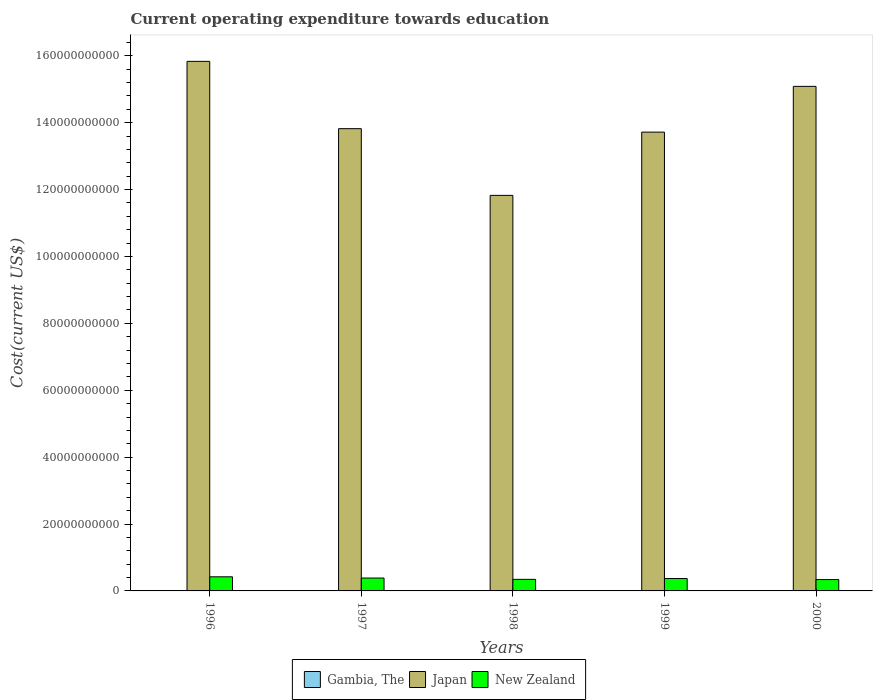How many different coloured bars are there?
Your answer should be very brief. 3. How many groups of bars are there?
Give a very brief answer. 5. How many bars are there on the 5th tick from the left?
Offer a terse response. 3. How many bars are there on the 5th tick from the right?
Give a very brief answer. 3. What is the label of the 5th group of bars from the left?
Your answer should be compact. 2000. In how many cases, is the number of bars for a given year not equal to the number of legend labels?
Ensure brevity in your answer.  0. What is the expenditure towards education in Japan in 2000?
Your answer should be very brief. 1.51e+11. Across all years, what is the maximum expenditure towards education in Japan?
Make the answer very short. 1.58e+11. Across all years, what is the minimum expenditure towards education in New Zealand?
Your response must be concise. 3.40e+09. What is the total expenditure towards education in Japan in the graph?
Keep it short and to the point. 7.03e+11. What is the difference between the expenditure towards education in Japan in 1997 and that in 2000?
Your answer should be compact. -1.26e+1. What is the difference between the expenditure towards education in Japan in 1998 and the expenditure towards education in New Zealand in 1996?
Provide a short and direct response. 1.14e+11. What is the average expenditure towards education in Japan per year?
Provide a short and direct response. 1.41e+11. In the year 2000, what is the difference between the expenditure towards education in Gambia, The and expenditure towards education in Japan?
Ensure brevity in your answer.  -1.51e+11. What is the ratio of the expenditure towards education in Gambia, The in 1996 to that in 1997?
Give a very brief answer. 1.07. Is the expenditure towards education in Gambia, The in 1997 less than that in 1998?
Provide a short and direct response. No. Is the difference between the expenditure towards education in Gambia, The in 1996 and 1997 greater than the difference between the expenditure towards education in Japan in 1996 and 1997?
Make the answer very short. No. What is the difference between the highest and the second highest expenditure towards education in New Zealand?
Make the answer very short. 3.69e+08. What is the difference between the highest and the lowest expenditure towards education in Gambia, The?
Keep it short and to the point. 3.53e+06. Is the sum of the expenditure towards education in New Zealand in 1997 and 1999 greater than the maximum expenditure towards education in Gambia, The across all years?
Give a very brief answer. Yes. What does the 3rd bar from the left in 2000 represents?
Your answer should be very brief. New Zealand. What does the 3rd bar from the right in 1996 represents?
Offer a terse response. Gambia, The. Is it the case that in every year, the sum of the expenditure towards education in Gambia, The and expenditure towards education in Japan is greater than the expenditure towards education in New Zealand?
Provide a short and direct response. Yes. How many bars are there?
Offer a very short reply. 15. How many years are there in the graph?
Ensure brevity in your answer.  5. How are the legend labels stacked?
Offer a terse response. Horizontal. What is the title of the graph?
Offer a terse response. Current operating expenditure towards education. Does "Seychelles" appear as one of the legend labels in the graph?
Your answer should be compact. No. What is the label or title of the X-axis?
Ensure brevity in your answer.  Years. What is the label or title of the Y-axis?
Provide a succinct answer. Cost(current US$). What is the Cost(current US$) of Gambia, The in 1996?
Make the answer very short. 1.33e+07. What is the Cost(current US$) in Japan in 1996?
Your response must be concise. 1.58e+11. What is the Cost(current US$) in New Zealand in 1996?
Offer a terse response. 4.22e+09. What is the Cost(current US$) of Gambia, The in 1997?
Your answer should be very brief. 1.25e+07. What is the Cost(current US$) in Japan in 1997?
Your answer should be very brief. 1.38e+11. What is the Cost(current US$) in New Zealand in 1997?
Give a very brief answer. 3.85e+09. What is the Cost(current US$) in Gambia, The in 1998?
Make the answer very short. 1.22e+07. What is the Cost(current US$) of Japan in 1998?
Provide a succinct answer. 1.18e+11. What is the Cost(current US$) of New Zealand in 1998?
Your response must be concise. 3.46e+09. What is the Cost(current US$) of Gambia, The in 1999?
Provide a succinct answer. 1.10e+07. What is the Cost(current US$) of Japan in 1999?
Your response must be concise. 1.37e+11. What is the Cost(current US$) of New Zealand in 1999?
Offer a very short reply. 3.70e+09. What is the Cost(current US$) of Gambia, The in 2000?
Offer a terse response. 9.78e+06. What is the Cost(current US$) in Japan in 2000?
Keep it short and to the point. 1.51e+11. What is the Cost(current US$) in New Zealand in 2000?
Make the answer very short. 3.40e+09. Across all years, what is the maximum Cost(current US$) of Gambia, The?
Ensure brevity in your answer.  1.33e+07. Across all years, what is the maximum Cost(current US$) of Japan?
Keep it short and to the point. 1.58e+11. Across all years, what is the maximum Cost(current US$) of New Zealand?
Your answer should be very brief. 4.22e+09. Across all years, what is the minimum Cost(current US$) in Gambia, The?
Provide a succinct answer. 9.78e+06. Across all years, what is the minimum Cost(current US$) in Japan?
Give a very brief answer. 1.18e+11. Across all years, what is the minimum Cost(current US$) in New Zealand?
Provide a short and direct response. 3.40e+09. What is the total Cost(current US$) in Gambia, The in the graph?
Keep it short and to the point. 5.88e+07. What is the total Cost(current US$) of Japan in the graph?
Your response must be concise. 7.03e+11. What is the total Cost(current US$) in New Zealand in the graph?
Provide a short and direct response. 1.86e+1. What is the difference between the Cost(current US$) of Gambia, The in 1996 and that in 1997?
Provide a succinct answer. 8.36e+05. What is the difference between the Cost(current US$) in Japan in 1996 and that in 1997?
Provide a short and direct response. 2.01e+1. What is the difference between the Cost(current US$) in New Zealand in 1996 and that in 1997?
Your response must be concise. 3.69e+08. What is the difference between the Cost(current US$) in Gambia, The in 1996 and that in 1998?
Offer a very short reply. 1.09e+06. What is the difference between the Cost(current US$) of Japan in 1996 and that in 1998?
Your answer should be very brief. 4.01e+1. What is the difference between the Cost(current US$) of New Zealand in 1996 and that in 1998?
Your response must be concise. 7.59e+08. What is the difference between the Cost(current US$) in Gambia, The in 1996 and that in 1999?
Your answer should be compact. 2.31e+06. What is the difference between the Cost(current US$) in Japan in 1996 and that in 1999?
Give a very brief answer. 2.12e+1. What is the difference between the Cost(current US$) of New Zealand in 1996 and that in 1999?
Make the answer very short. 5.18e+08. What is the difference between the Cost(current US$) of Gambia, The in 1996 and that in 2000?
Offer a terse response. 3.53e+06. What is the difference between the Cost(current US$) in Japan in 1996 and that in 2000?
Your response must be concise. 7.48e+09. What is the difference between the Cost(current US$) of New Zealand in 1996 and that in 2000?
Your response must be concise. 8.20e+08. What is the difference between the Cost(current US$) of Gambia, The in 1997 and that in 1998?
Your response must be concise. 2.53e+05. What is the difference between the Cost(current US$) in Japan in 1997 and that in 1998?
Give a very brief answer. 1.99e+1. What is the difference between the Cost(current US$) of New Zealand in 1997 and that in 1998?
Make the answer very short. 3.91e+08. What is the difference between the Cost(current US$) in Gambia, The in 1997 and that in 1999?
Give a very brief answer. 1.48e+06. What is the difference between the Cost(current US$) in Japan in 1997 and that in 1999?
Your answer should be very brief. 1.03e+09. What is the difference between the Cost(current US$) of New Zealand in 1997 and that in 1999?
Offer a very short reply. 1.50e+08. What is the difference between the Cost(current US$) in Gambia, The in 1997 and that in 2000?
Give a very brief answer. 2.69e+06. What is the difference between the Cost(current US$) of Japan in 1997 and that in 2000?
Offer a very short reply. -1.26e+1. What is the difference between the Cost(current US$) of New Zealand in 1997 and that in 2000?
Ensure brevity in your answer.  4.51e+08. What is the difference between the Cost(current US$) in Gambia, The in 1998 and that in 1999?
Ensure brevity in your answer.  1.22e+06. What is the difference between the Cost(current US$) in Japan in 1998 and that in 1999?
Your answer should be very brief. -1.89e+1. What is the difference between the Cost(current US$) of New Zealand in 1998 and that in 1999?
Your answer should be compact. -2.41e+08. What is the difference between the Cost(current US$) in Gambia, The in 1998 and that in 2000?
Give a very brief answer. 2.44e+06. What is the difference between the Cost(current US$) of Japan in 1998 and that in 2000?
Offer a very short reply. -3.26e+1. What is the difference between the Cost(current US$) in New Zealand in 1998 and that in 2000?
Offer a very short reply. 6.07e+07. What is the difference between the Cost(current US$) of Gambia, The in 1999 and that in 2000?
Ensure brevity in your answer.  1.22e+06. What is the difference between the Cost(current US$) of Japan in 1999 and that in 2000?
Your answer should be very brief. -1.37e+1. What is the difference between the Cost(current US$) of New Zealand in 1999 and that in 2000?
Your response must be concise. 3.02e+08. What is the difference between the Cost(current US$) of Gambia, The in 1996 and the Cost(current US$) of Japan in 1997?
Offer a terse response. -1.38e+11. What is the difference between the Cost(current US$) in Gambia, The in 1996 and the Cost(current US$) in New Zealand in 1997?
Your answer should be very brief. -3.84e+09. What is the difference between the Cost(current US$) in Japan in 1996 and the Cost(current US$) in New Zealand in 1997?
Your response must be concise. 1.54e+11. What is the difference between the Cost(current US$) in Gambia, The in 1996 and the Cost(current US$) in Japan in 1998?
Ensure brevity in your answer.  -1.18e+11. What is the difference between the Cost(current US$) of Gambia, The in 1996 and the Cost(current US$) of New Zealand in 1998?
Make the answer very short. -3.45e+09. What is the difference between the Cost(current US$) in Japan in 1996 and the Cost(current US$) in New Zealand in 1998?
Make the answer very short. 1.55e+11. What is the difference between the Cost(current US$) in Gambia, The in 1996 and the Cost(current US$) in Japan in 1999?
Offer a terse response. -1.37e+11. What is the difference between the Cost(current US$) in Gambia, The in 1996 and the Cost(current US$) in New Zealand in 1999?
Offer a terse response. -3.69e+09. What is the difference between the Cost(current US$) in Japan in 1996 and the Cost(current US$) in New Zealand in 1999?
Your answer should be compact. 1.55e+11. What is the difference between the Cost(current US$) of Gambia, The in 1996 and the Cost(current US$) of Japan in 2000?
Offer a very short reply. -1.51e+11. What is the difference between the Cost(current US$) of Gambia, The in 1996 and the Cost(current US$) of New Zealand in 2000?
Offer a very short reply. -3.39e+09. What is the difference between the Cost(current US$) in Japan in 1996 and the Cost(current US$) in New Zealand in 2000?
Give a very brief answer. 1.55e+11. What is the difference between the Cost(current US$) of Gambia, The in 1997 and the Cost(current US$) of Japan in 1998?
Give a very brief answer. -1.18e+11. What is the difference between the Cost(current US$) of Gambia, The in 1997 and the Cost(current US$) of New Zealand in 1998?
Keep it short and to the point. -3.45e+09. What is the difference between the Cost(current US$) of Japan in 1997 and the Cost(current US$) of New Zealand in 1998?
Your answer should be compact. 1.35e+11. What is the difference between the Cost(current US$) of Gambia, The in 1997 and the Cost(current US$) of Japan in 1999?
Your answer should be very brief. -1.37e+11. What is the difference between the Cost(current US$) in Gambia, The in 1997 and the Cost(current US$) in New Zealand in 1999?
Your answer should be very brief. -3.69e+09. What is the difference between the Cost(current US$) of Japan in 1997 and the Cost(current US$) of New Zealand in 1999?
Provide a succinct answer. 1.35e+11. What is the difference between the Cost(current US$) of Gambia, The in 1997 and the Cost(current US$) of Japan in 2000?
Provide a short and direct response. -1.51e+11. What is the difference between the Cost(current US$) in Gambia, The in 1997 and the Cost(current US$) in New Zealand in 2000?
Your response must be concise. -3.39e+09. What is the difference between the Cost(current US$) in Japan in 1997 and the Cost(current US$) in New Zealand in 2000?
Ensure brevity in your answer.  1.35e+11. What is the difference between the Cost(current US$) of Gambia, The in 1998 and the Cost(current US$) of Japan in 1999?
Provide a succinct answer. -1.37e+11. What is the difference between the Cost(current US$) of Gambia, The in 1998 and the Cost(current US$) of New Zealand in 1999?
Offer a very short reply. -3.69e+09. What is the difference between the Cost(current US$) of Japan in 1998 and the Cost(current US$) of New Zealand in 1999?
Offer a very short reply. 1.15e+11. What is the difference between the Cost(current US$) in Gambia, The in 1998 and the Cost(current US$) in Japan in 2000?
Your answer should be very brief. -1.51e+11. What is the difference between the Cost(current US$) in Gambia, The in 1998 and the Cost(current US$) in New Zealand in 2000?
Ensure brevity in your answer.  -3.39e+09. What is the difference between the Cost(current US$) in Japan in 1998 and the Cost(current US$) in New Zealand in 2000?
Your answer should be very brief. 1.15e+11. What is the difference between the Cost(current US$) of Gambia, The in 1999 and the Cost(current US$) of Japan in 2000?
Your answer should be compact. -1.51e+11. What is the difference between the Cost(current US$) in Gambia, The in 1999 and the Cost(current US$) in New Zealand in 2000?
Give a very brief answer. -3.39e+09. What is the difference between the Cost(current US$) in Japan in 1999 and the Cost(current US$) in New Zealand in 2000?
Offer a very short reply. 1.34e+11. What is the average Cost(current US$) of Gambia, The per year?
Provide a succinct answer. 1.18e+07. What is the average Cost(current US$) of Japan per year?
Provide a succinct answer. 1.41e+11. What is the average Cost(current US$) of New Zealand per year?
Provide a short and direct response. 3.73e+09. In the year 1996, what is the difference between the Cost(current US$) of Gambia, The and Cost(current US$) of Japan?
Give a very brief answer. -1.58e+11. In the year 1996, what is the difference between the Cost(current US$) in Gambia, The and Cost(current US$) in New Zealand?
Make the answer very short. -4.21e+09. In the year 1996, what is the difference between the Cost(current US$) of Japan and Cost(current US$) of New Zealand?
Keep it short and to the point. 1.54e+11. In the year 1997, what is the difference between the Cost(current US$) of Gambia, The and Cost(current US$) of Japan?
Keep it short and to the point. -1.38e+11. In the year 1997, what is the difference between the Cost(current US$) of Gambia, The and Cost(current US$) of New Zealand?
Offer a very short reply. -3.84e+09. In the year 1997, what is the difference between the Cost(current US$) of Japan and Cost(current US$) of New Zealand?
Provide a short and direct response. 1.34e+11. In the year 1998, what is the difference between the Cost(current US$) in Gambia, The and Cost(current US$) in Japan?
Your answer should be very brief. -1.18e+11. In the year 1998, what is the difference between the Cost(current US$) of Gambia, The and Cost(current US$) of New Zealand?
Provide a succinct answer. -3.45e+09. In the year 1998, what is the difference between the Cost(current US$) in Japan and Cost(current US$) in New Zealand?
Keep it short and to the point. 1.15e+11. In the year 1999, what is the difference between the Cost(current US$) of Gambia, The and Cost(current US$) of Japan?
Offer a very short reply. -1.37e+11. In the year 1999, what is the difference between the Cost(current US$) of Gambia, The and Cost(current US$) of New Zealand?
Offer a terse response. -3.69e+09. In the year 1999, what is the difference between the Cost(current US$) of Japan and Cost(current US$) of New Zealand?
Ensure brevity in your answer.  1.33e+11. In the year 2000, what is the difference between the Cost(current US$) of Gambia, The and Cost(current US$) of Japan?
Provide a succinct answer. -1.51e+11. In the year 2000, what is the difference between the Cost(current US$) in Gambia, The and Cost(current US$) in New Zealand?
Ensure brevity in your answer.  -3.39e+09. In the year 2000, what is the difference between the Cost(current US$) in Japan and Cost(current US$) in New Zealand?
Offer a terse response. 1.47e+11. What is the ratio of the Cost(current US$) of Gambia, The in 1996 to that in 1997?
Provide a succinct answer. 1.07. What is the ratio of the Cost(current US$) of Japan in 1996 to that in 1997?
Your answer should be very brief. 1.15. What is the ratio of the Cost(current US$) in New Zealand in 1996 to that in 1997?
Your answer should be compact. 1.1. What is the ratio of the Cost(current US$) of Gambia, The in 1996 to that in 1998?
Make the answer very short. 1.09. What is the ratio of the Cost(current US$) in Japan in 1996 to that in 1998?
Ensure brevity in your answer.  1.34. What is the ratio of the Cost(current US$) of New Zealand in 1996 to that in 1998?
Keep it short and to the point. 1.22. What is the ratio of the Cost(current US$) in Gambia, The in 1996 to that in 1999?
Give a very brief answer. 1.21. What is the ratio of the Cost(current US$) in Japan in 1996 to that in 1999?
Offer a terse response. 1.15. What is the ratio of the Cost(current US$) in New Zealand in 1996 to that in 1999?
Make the answer very short. 1.14. What is the ratio of the Cost(current US$) in Gambia, The in 1996 to that in 2000?
Offer a terse response. 1.36. What is the ratio of the Cost(current US$) in Japan in 1996 to that in 2000?
Your answer should be compact. 1.05. What is the ratio of the Cost(current US$) in New Zealand in 1996 to that in 2000?
Offer a very short reply. 1.24. What is the ratio of the Cost(current US$) of Gambia, The in 1997 to that in 1998?
Offer a terse response. 1.02. What is the ratio of the Cost(current US$) of Japan in 1997 to that in 1998?
Give a very brief answer. 1.17. What is the ratio of the Cost(current US$) of New Zealand in 1997 to that in 1998?
Your answer should be very brief. 1.11. What is the ratio of the Cost(current US$) in Gambia, The in 1997 to that in 1999?
Make the answer very short. 1.13. What is the ratio of the Cost(current US$) of Japan in 1997 to that in 1999?
Make the answer very short. 1.01. What is the ratio of the Cost(current US$) in New Zealand in 1997 to that in 1999?
Your answer should be compact. 1.04. What is the ratio of the Cost(current US$) in Gambia, The in 1997 to that in 2000?
Make the answer very short. 1.28. What is the ratio of the Cost(current US$) of Japan in 1997 to that in 2000?
Offer a very short reply. 0.92. What is the ratio of the Cost(current US$) of New Zealand in 1997 to that in 2000?
Give a very brief answer. 1.13. What is the ratio of the Cost(current US$) of Gambia, The in 1998 to that in 1999?
Provide a short and direct response. 1.11. What is the ratio of the Cost(current US$) of Japan in 1998 to that in 1999?
Provide a succinct answer. 0.86. What is the ratio of the Cost(current US$) of New Zealand in 1998 to that in 1999?
Give a very brief answer. 0.93. What is the ratio of the Cost(current US$) in Gambia, The in 1998 to that in 2000?
Give a very brief answer. 1.25. What is the ratio of the Cost(current US$) in Japan in 1998 to that in 2000?
Your answer should be very brief. 0.78. What is the ratio of the Cost(current US$) of New Zealand in 1998 to that in 2000?
Provide a succinct answer. 1.02. What is the ratio of the Cost(current US$) of Gambia, The in 1999 to that in 2000?
Your response must be concise. 1.12. What is the ratio of the Cost(current US$) of Japan in 1999 to that in 2000?
Ensure brevity in your answer.  0.91. What is the ratio of the Cost(current US$) of New Zealand in 1999 to that in 2000?
Your answer should be compact. 1.09. What is the difference between the highest and the second highest Cost(current US$) of Gambia, The?
Your answer should be compact. 8.36e+05. What is the difference between the highest and the second highest Cost(current US$) of Japan?
Provide a succinct answer. 7.48e+09. What is the difference between the highest and the second highest Cost(current US$) of New Zealand?
Provide a short and direct response. 3.69e+08. What is the difference between the highest and the lowest Cost(current US$) of Gambia, The?
Provide a succinct answer. 3.53e+06. What is the difference between the highest and the lowest Cost(current US$) in Japan?
Keep it short and to the point. 4.01e+1. What is the difference between the highest and the lowest Cost(current US$) in New Zealand?
Offer a very short reply. 8.20e+08. 